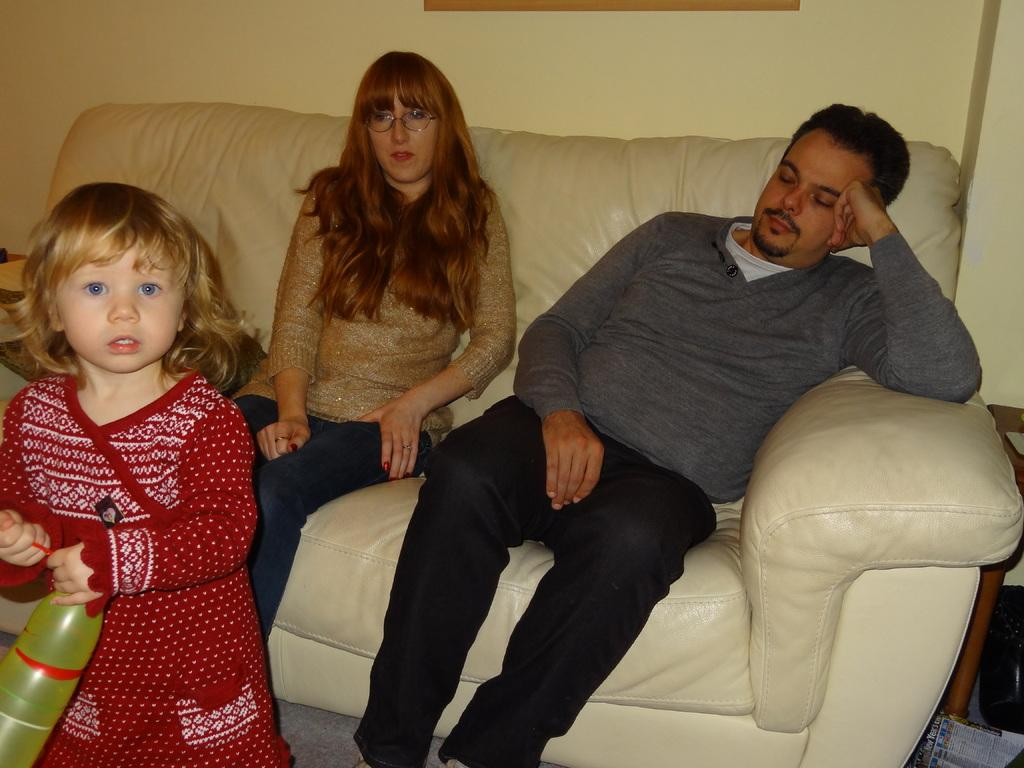How many people are in the image? There are three people in the image: a man, a woman, and a child. What are the man and woman doing in the image? The man and woman are sitting on a couch in the image. What is the child holding in the image? The child is holding a balloon in the image. Where is the child standing in the image? The child is standing on the floor in the image. What type of noise can be heard coming from the trail in the image? There is no trail present in the image, and therefore no noise can be heard from it. 